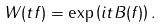Convert formula to latex. <formula><loc_0><loc_0><loc_500><loc_500>W ( t f ) = \exp \left ( i t B ( f ) \right ) .</formula> 